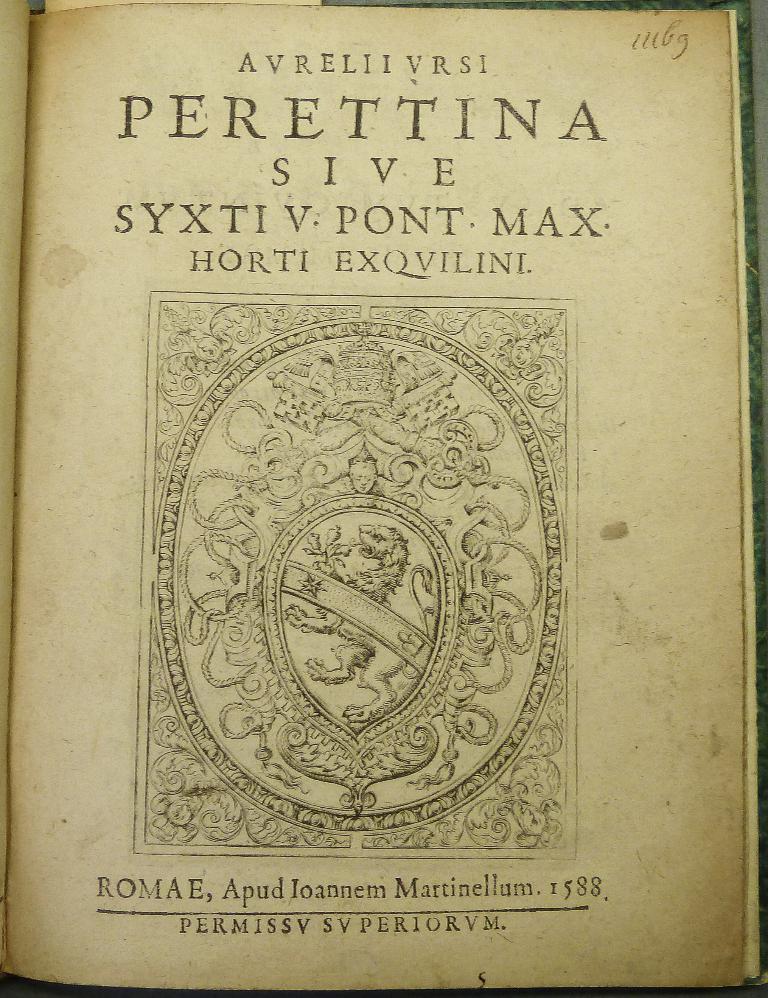What year is this book from?
Keep it short and to the point. 1588. What is written directly above the picture?
Offer a terse response. Horti exqvilini. 